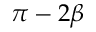Convert formula to latex. <formula><loc_0><loc_0><loc_500><loc_500>\pi - 2 \beta</formula> 